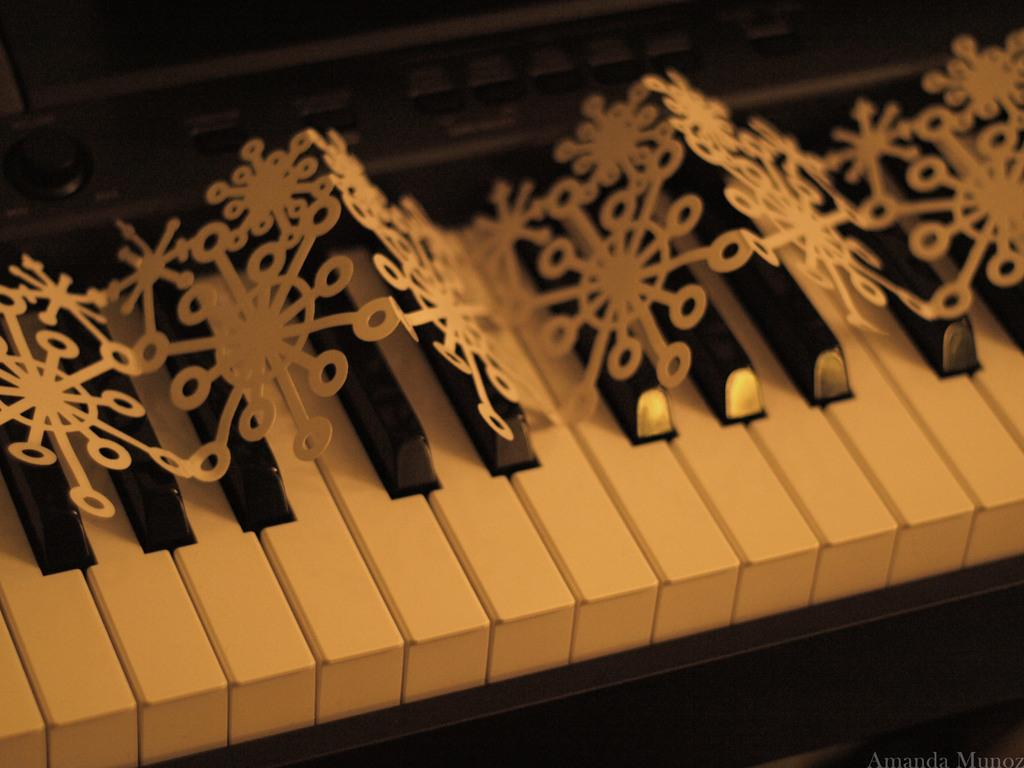What object is covered in snowflakes in the image? There are snowflakes on a piano in the image. What type of weather might be suggested by the presence of snowflakes? The presence of snowflakes suggests cold weather or snowfall. What might be the reason for the snowflakes on the piano? It could be due to recent snowfall or a decorative effect. What type of cub can be seen playing with the piano in the image? There is no cub present in the image; it features a piano covered in snowflakes. What type of print is visible on the piano in the image? There is no print visible on the piano in the image; it is covered in snowflakes. 